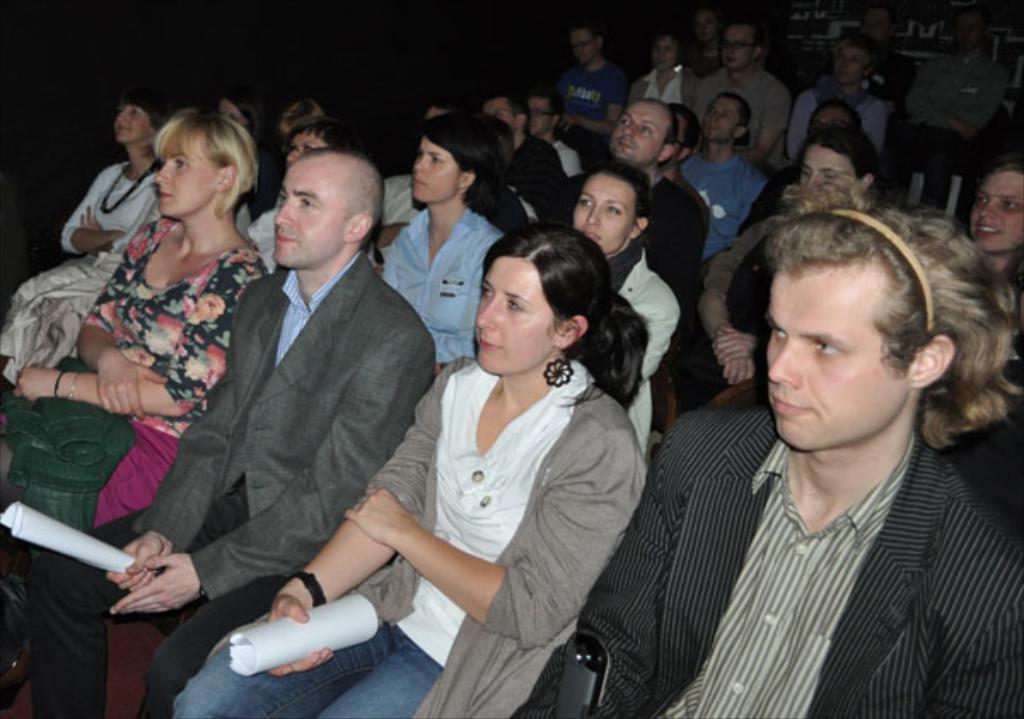Can you describe this image briefly? In the image there are many people sitting. In front of the image there are two people holding the papers in their hands. There is a black background. 